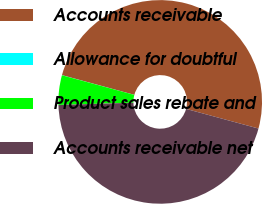Convert chart. <chart><loc_0><loc_0><loc_500><loc_500><pie_chart><fcel>Accounts receivable<fcel>Allowance for doubtful<fcel>Product sales rebate and<fcel>Accounts receivable net<nl><fcel>49.98%<fcel>0.02%<fcel>4.69%<fcel>45.31%<nl></chart> 